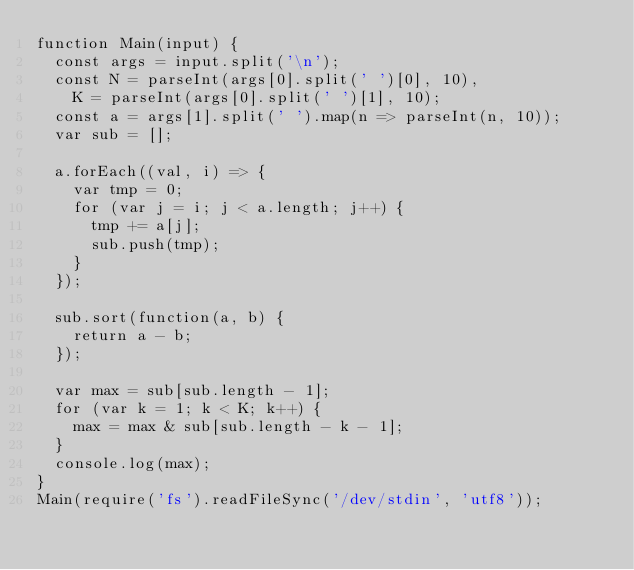Convert code to text. <code><loc_0><loc_0><loc_500><loc_500><_JavaScript_>function Main(input) {
  const args = input.split('\n');
  const N = parseInt(args[0].split(' ')[0], 10),
    K = parseInt(args[0].split(' ')[1], 10);
  const a = args[1].split(' ').map(n => parseInt(n, 10));
  var sub = [];

  a.forEach((val, i) => {
    var tmp = 0;
    for (var j = i; j < a.length; j++) {
      tmp += a[j];
      sub.push(tmp);
    }
  });

  sub.sort(function(a, b) {
    return a - b;
  });

  var max = sub[sub.length - 1];
  for (var k = 1; k < K; k++) {
    max = max & sub[sub.length - k - 1];
  }
  console.log(max);
}
Main(require('fs').readFileSync('/dev/stdin', 'utf8'));
</code> 